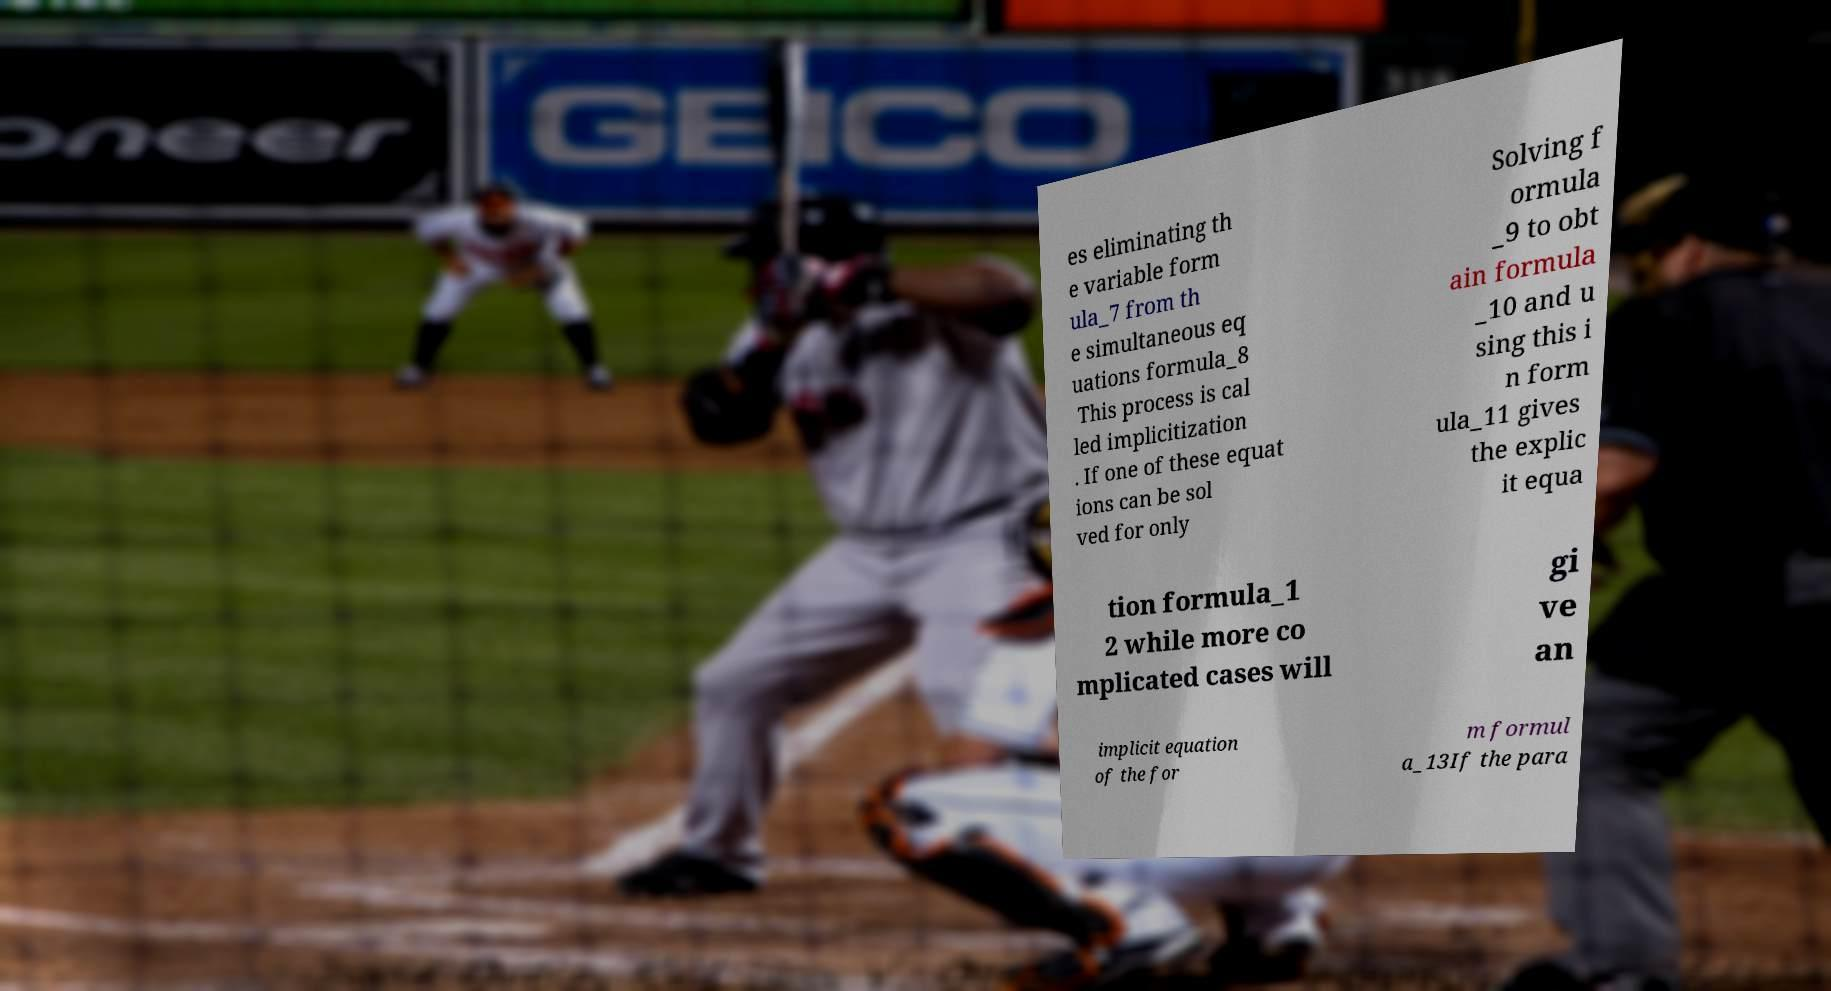There's text embedded in this image that I need extracted. Can you transcribe it verbatim? es eliminating th e variable form ula_7 from th e simultaneous eq uations formula_8 This process is cal led implicitization . If one of these equat ions can be sol ved for only Solving f ormula _9 to obt ain formula _10 and u sing this i n form ula_11 gives the explic it equa tion formula_1 2 while more co mplicated cases will gi ve an implicit equation of the for m formul a_13If the para 